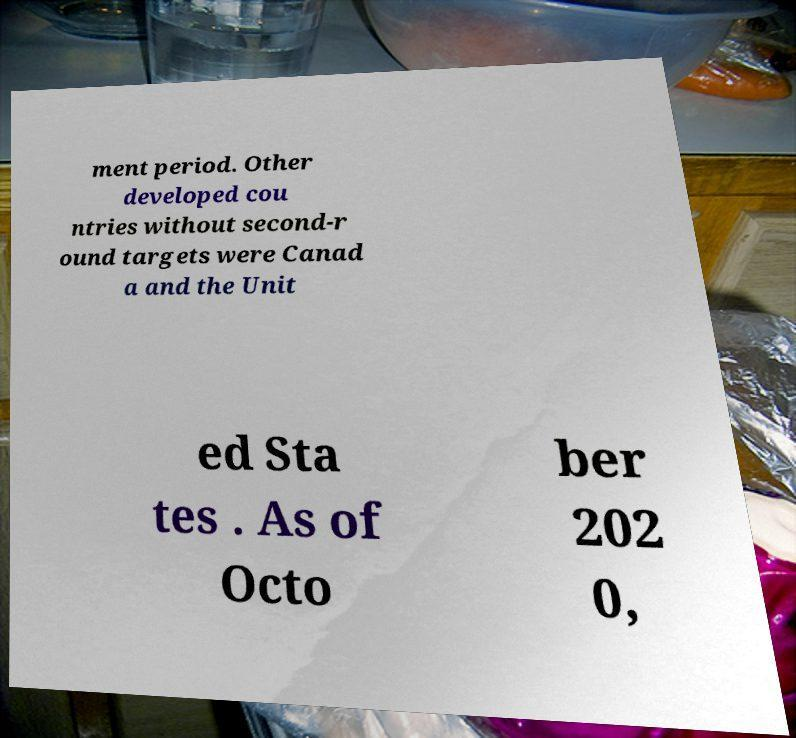Can you read and provide the text displayed in the image?This photo seems to have some interesting text. Can you extract and type it out for me? ment period. Other developed cou ntries without second-r ound targets were Canad a and the Unit ed Sta tes . As of Octo ber 202 0, 